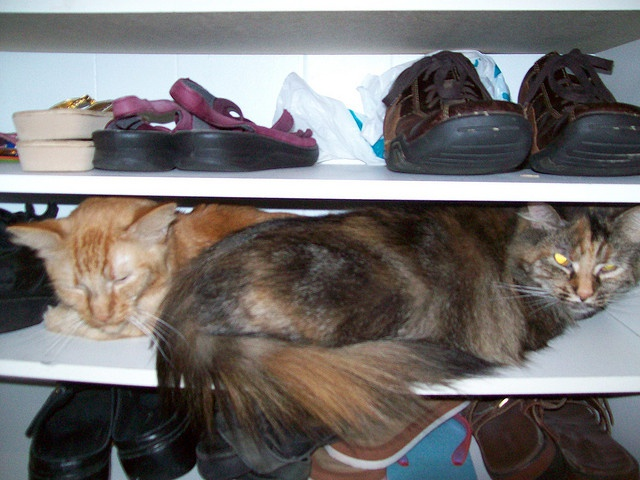Describe the objects in this image and their specific colors. I can see cat in lightgray, black, and gray tones and cat in lightgray, tan, gray, and darkgray tones in this image. 